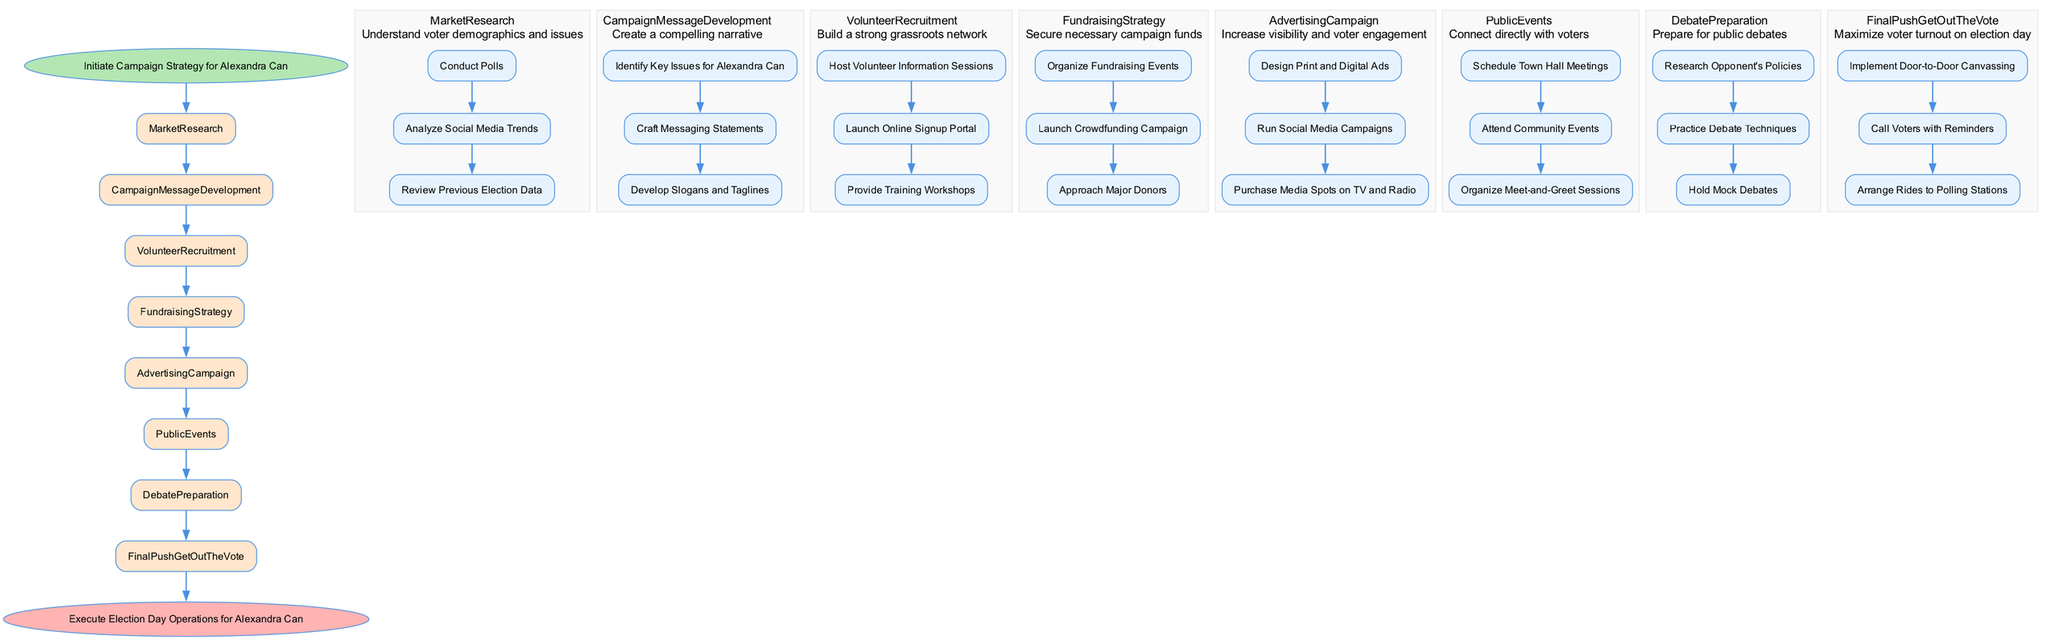What is the starting point of the campaign strategy? The starting point of the campaign strategy is indicated in the diagram as "Initiate Campaign Strategy for Alexandra Can," which is the first node that begins the flow of processes.
Answer: Initiate Campaign Strategy for Alexandra Can How many main steps are there in the campaign strategy? By counting the main categories listed in the diagram, which include Market Research, Campaign Message Development, Volunteer Recruitment, Fundraising Strategy, Advertising Campaign, Public Events, Debate Preparation, and Final Push Get Out The Vote, we find that there are a total of eight main steps.
Answer: 8 What is the goal of the Fundraising Strategy step? The goal for the Fundraising Strategy step is stated as "Secure necessary campaign funds," which is the primary objective of this particular section within the flowchart.
Answer: Secure necessary campaign funds Which step precedes Debate Preparation? Looking at the flow of the diagram, the step that comes before Debate Preparation is Public Events, as each step connects sequentially from one to the next.
Answer: Public Events What type of sessions are scheduled in the Public Events step? According to the sub-steps listed under Public Events, the sessions scheduled include "Schedule Town Hall Meetings," which is aimed at connecting directly with voters.
Answer: Schedule Town Hall Meetings How many steps are involved in the Advertising Campaign section? By reviewing the Advertising Campaign section in the diagram, we see there are three steps involved: Design Print and Digital Ads, Run Social Media Campaigns, and Purchase Media Spots on TV and Radio, which are all necessary for the campaign's visibility.
Answer: 3 What is the final action in the campaign flow? The final action indicated in the flow chart, which captures the last phase of the campaign process, is "Execute Election Day Operations for Alexandra Can," demonstrating the culmination of all preceding efforts on election day.
Answer: Execute Election Day Operations for Alexandra Can What is the goal of the Final Push Get Out The Vote step? The goal outlined for the Final Push Get Out The Vote step is to "Maximize voter turnout on election day," emphasizing its importance in achieving a successful election outcome.
Answer: Maximize voter turnout on election day 